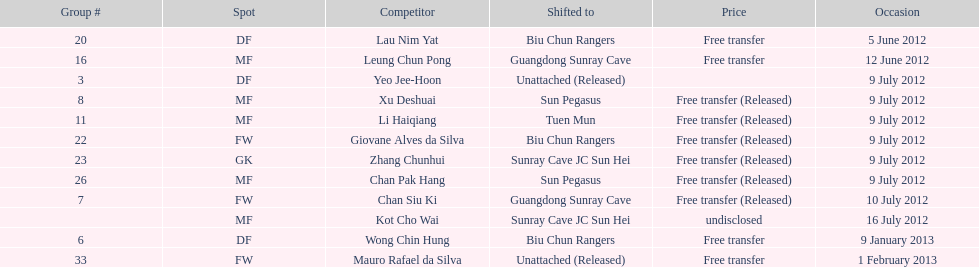How many consecutive players were released on july 9? 6. 